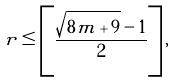<formula> <loc_0><loc_0><loc_500><loc_500>r \leq \left [ \frac { \sqrt { 8 m + 9 } - 1 } { 2 } \right ] ,</formula> 